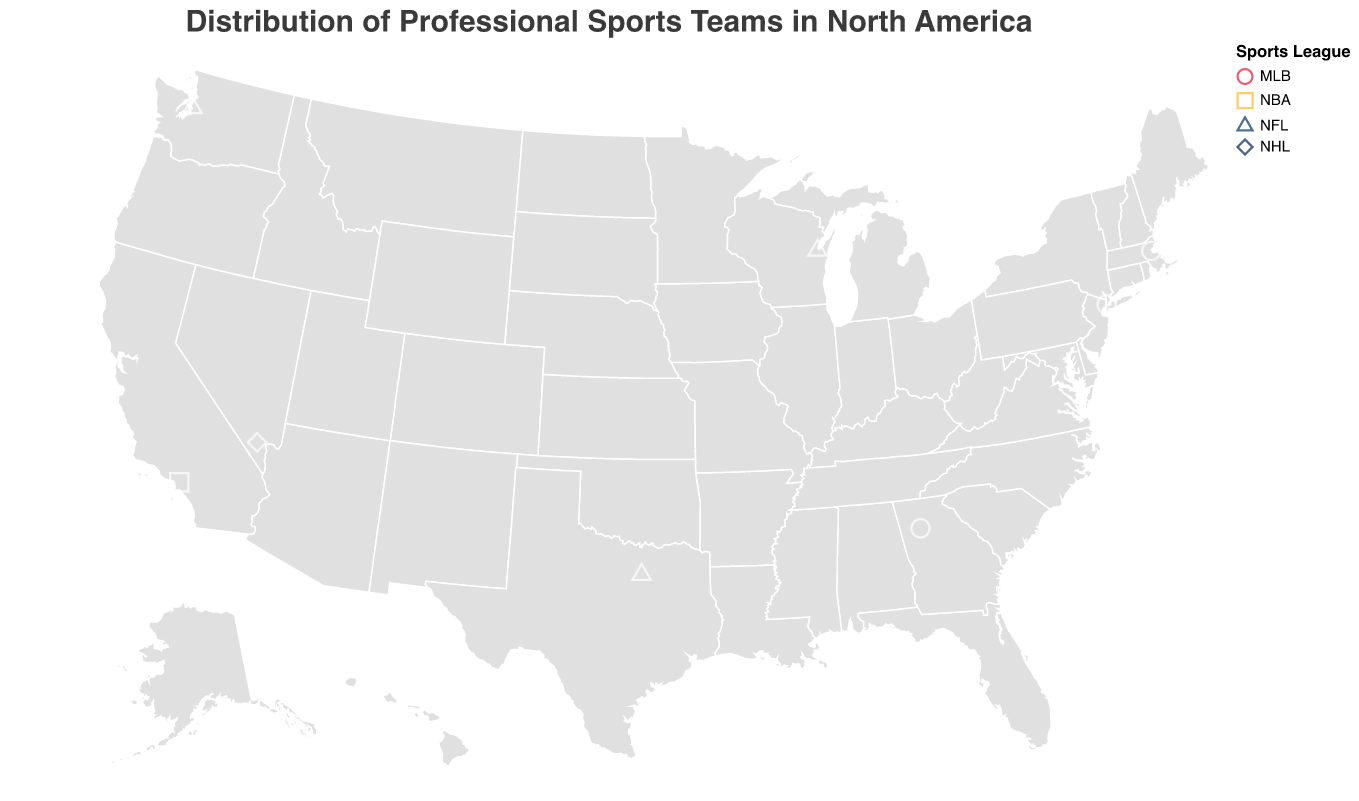What's the title of the figure? The title is usually positioned at the top of the figure. In this case, it is stated as "Distribution of Professional Sports Teams in North America".
Answer: Distribution of Professional Sports Teams in North America How many NFL teams are shown in the figure? Identify the teams with the league marked as "NFL" by looking at the shape and color assigned to that league. The teams are: Green Bay Packers, Dallas Cowboys, Seattle Seahawks. That's three teams.
Answer: 3 Which city has the most professional sports teams represented? By observing the city names and counting each occurrence, only the city of Los Angeles appears more than once (Los Angeles Lakers).
Answer: Los Angeles Which team is located farthest north? Compare the latitudes of all teams. The team with the highest latitude value is farthest north, which is Montreal Canadiens at a latitude of 45.4958.
Answer: Montreal Canadiens What is the primary color used to represent NBA teams in the figure? Identify the color assigned to the NBA teams by looking at the legend. The color for NBA is yellow (represented by the Toronto Raptors and Los Angeles Lakers).
Answer: Yellow What is the shape used to represent NHL teams? Look at the legend to see which shape is used for NHL (National Hockey League) teams. The diamond shape is used for NHL teams.
Answer: Diamond Which stadium is located in the southeastern United States? Locate the southeastern region of the map and identify the team and their stadium within that geographic area. It's the Atlanta Braves with Truist Park in Georgia.
Answer: Truist Park How does the distribution of MLB teams compare to NFL teams in the eastern United States? Identify the MLB and NFL teams situated in the eastern part of the U.S. MLB teams are New York Yankees, Boston Red Sox, Atlanta Braves; NFL teams are Green Bay Packers, Dallas Cowboys, Seattle Seahawks. By visual inspection, more MLB teams are in the east compared to NFL teams.
Answer: MLB has more teams in the east Which league has teams most spread across North America geographically? Look at the geographical spread of teams, observing their locations. The NFL teams (Green Bay Packers, Dallas Cowboys, Seattle Seahawks) are spread from central to both coasts of the USA, showing wide distribution.
Answer: NFL How many teams are based outside of the USA? Identify teams based in Canada by checking their city and country. These include Montreal Canadiens and Toronto Raptors. There are two such teams.
Answer: 2 